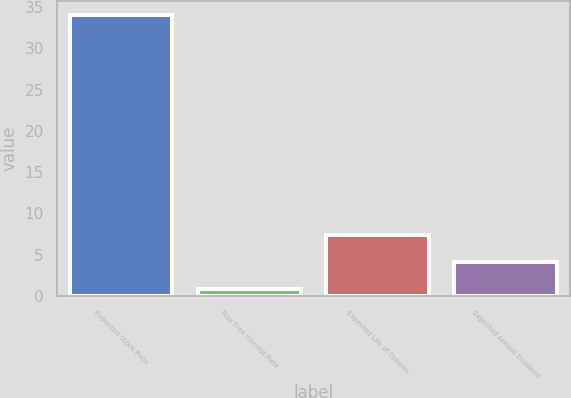Convert chart. <chart><loc_0><loc_0><loc_500><loc_500><bar_chart><fcel>Expected Stock Price<fcel>Risk Free Interest Rate<fcel>Expected Life of Options<fcel>Expected Annual Dividend<nl><fcel>34<fcel>0.8<fcel>7.44<fcel>4.12<nl></chart> 